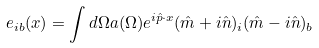<formula> <loc_0><loc_0><loc_500><loc_500>e _ { i b } ( x ) = \int d \Omega a ( \Omega ) e ^ { i \hat { p } \cdot x } ( \hat { m } + i \hat { n } ) _ { i } ( \hat { m } - i \hat { n } ) _ { b }</formula> 